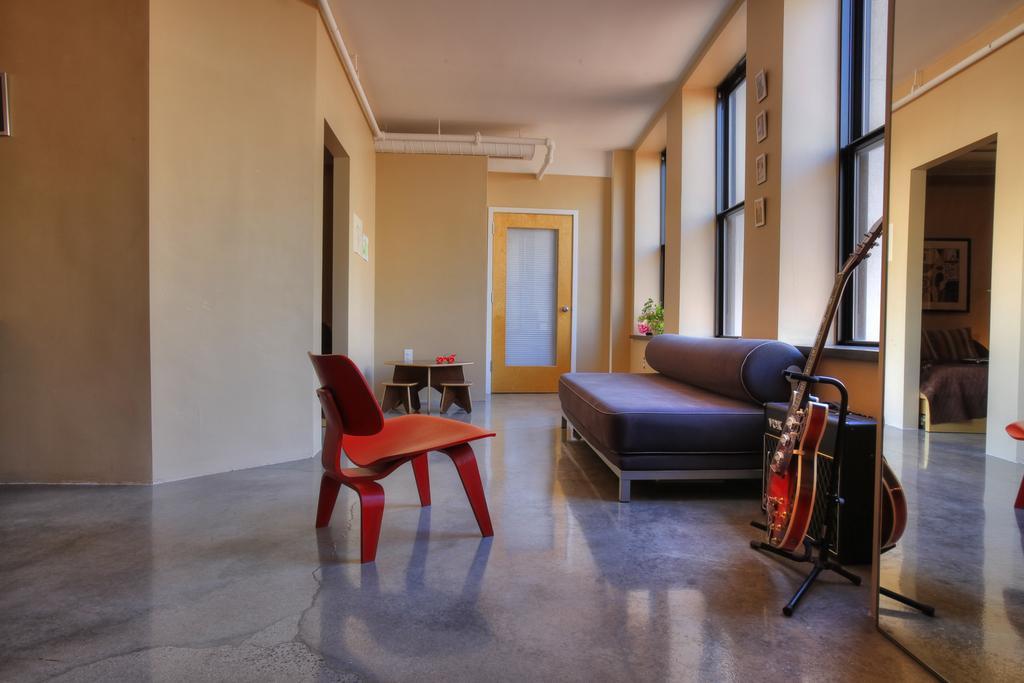In one or two sentences, can you explain what this image depicts? In this picture there is a diwan cot, guitar and a table with a chair in this room. In the background there is a door, wall and some windows here. 